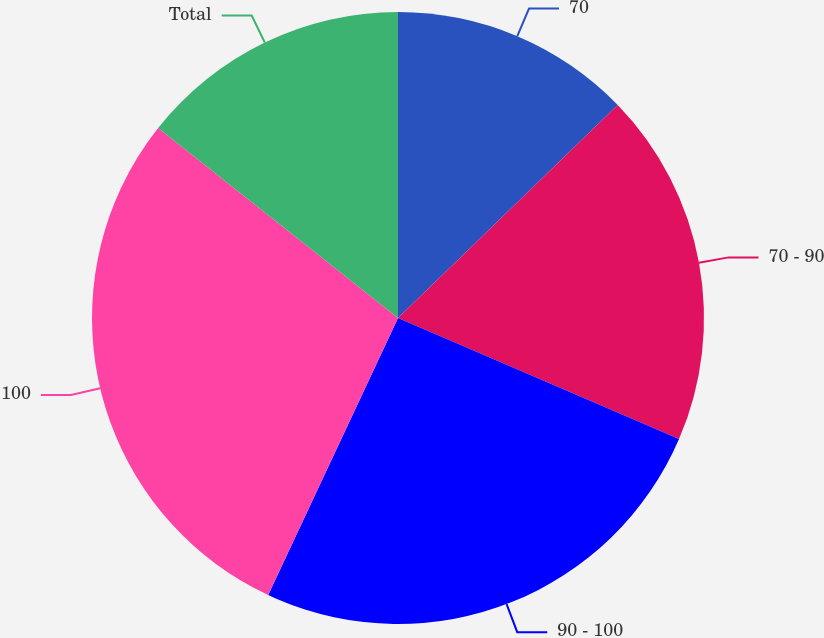<chart> <loc_0><loc_0><loc_500><loc_500><pie_chart><fcel>70<fcel>70 - 90<fcel>90 - 100<fcel>100<fcel>Total<nl><fcel>12.75%<fcel>18.73%<fcel>25.5%<fcel>28.69%<fcel>14.34%<nl></chart> 